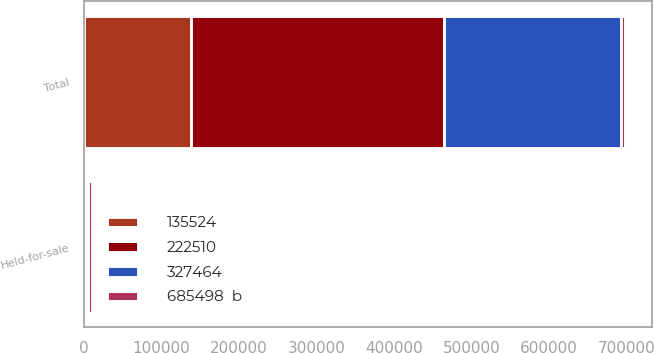Convert chart. <chart><loc_0><loc_0><loc_500><loc_500><stacked_bar_chart><ecel><fcel>Held-for-sale<fcel>Total<nl><fcel>327464<fcel>3147<fcel>227633<nl><fcel>222510<fcel>154<fcel>327618<nl><fcel>135524<fcel>2152<fcel>137676<nl><fcel>685498  b<fcel>5453<fcel>5453<nl></chart> 